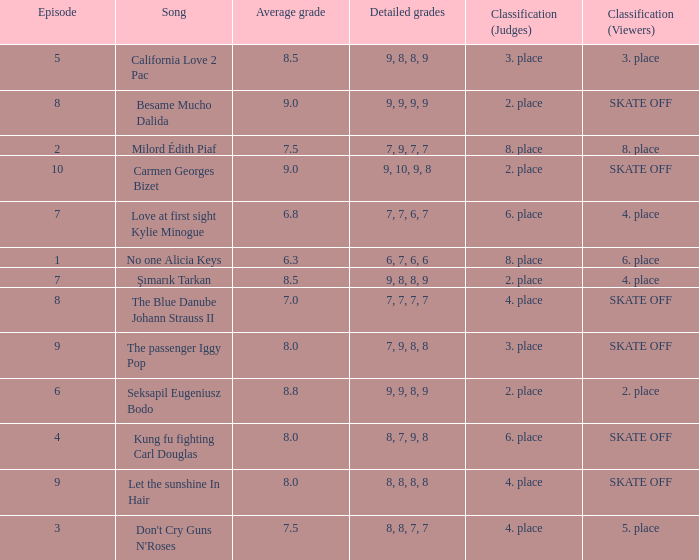Name the classification for 9, 9, 8, 9 2. place. 